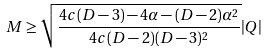Convert formula to latex. <formula><loc_0><loc_0><loc_500><loc_500>M \geq \sqrt { \frac { 4 c ( D - 3 ) - 4 \alpha - ( D - 2 ) \alpha ^ { 2 } } { 4 c ( D - 2 ) ( D - 3 ) ^ { 2 } } } | Q |</formula> 